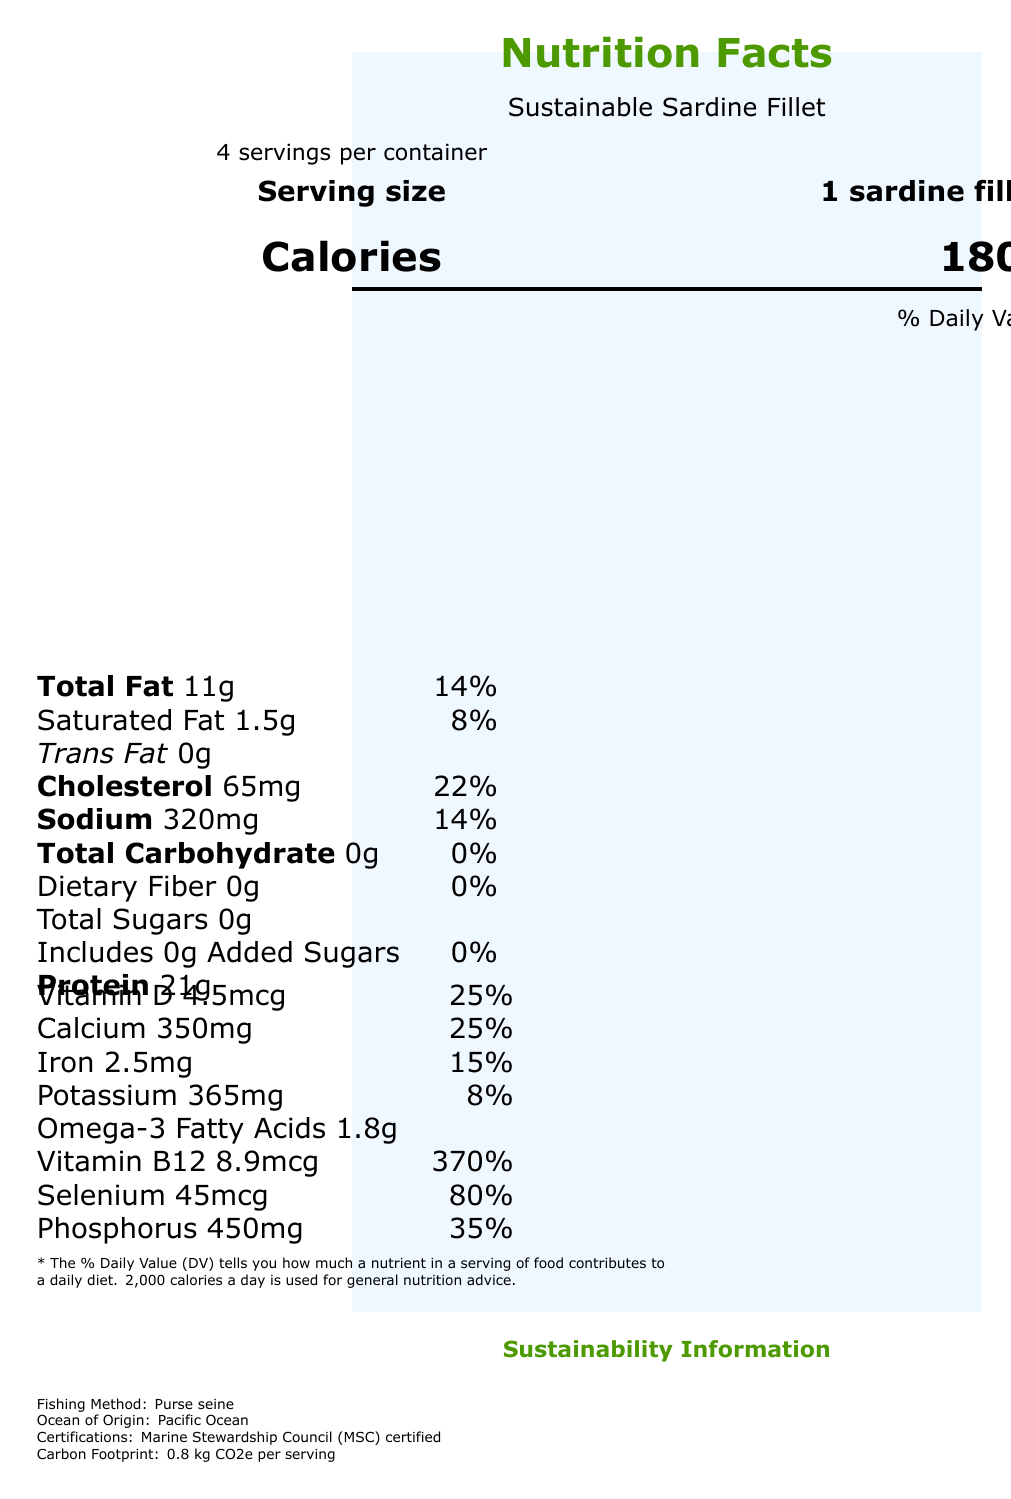what is the serving size? The serving size is mentioned as "1 sardine fillet (85g)" in the serving information section of the document.
Answer: 1 sardine fillet (85g) how many servings are there per container? The document states there are "4 servings per container" in the serving information section.
Answer: 4 how many calories are in one serving? The calorie information section indicates that there are 180 calories in one serving.
Answer: 180 what is the daily value percentage of saturated fat? The document lists the daily value percentage of saturated fat as 8%.
Answer: 8% how much protein does one serving contain? The nutrient table shows one serving contains 21 grams of protein.
Answer: 21g what type of fishing method is used for the sardines? The sustainability information section states that the fishing method used is "Purse seine".
Answer: Purse seine how much omega-3 fatty acids does one serving contain? The vitamin and mineral table lists 1.8 grams of omega-3 fatty acids per serving.
Answer: 1.8g which organization certified the sustainability of the sardines? The certifications are listed under sustainability information, where it mentions "Marine Stewardship Council (MSC) certified".
Answer: Marine Stewardship Council (MSC) what percentage of daily calcium value does one serving provide? The vitamin and mineral table shows that one serving provides 25% of the daily value for calcium.
Answer: 25% the document mentions three preparation tips for sardines. (Choose one not listed) A. Grill with lemon and herbs B. Bake with garlic and tomatoes C. Mash with avocado D. Add to pasta dishes The preparation tips listed are "Grill with lemon and herbs," "Mash with avocado," and "Add to pasta dishes." "Bake with garlic and tomatoes" is not listed.
Answer: B what is the carbon footprint per serving of this fish dish? A. 0.5 kg CO2e B. 0.8 kg CO2e C. 1.0 kg CO2e D. 1.2 kg CO2e The sustainability information section lists the carbon footprint per serving as "0.8 kg CO2e."
Answer: B is there any added sugar in the sardine fillet? The document shows the amount of added sugars as "0g" and a daily value of "0%," indicating no added sugars.
Answer: No summarize the main idea of the document. The document offers a comprehensive overview of the nutritional values, environmental benefits, and certification information for sardines, emphasizing their sustainability and health advantages.
Answer: The document provides detailed nutrition information for a sustainable sardine fillet, including serving size, calories, nutrient content, and daily value percentages. It highlights the sustainability aspects of the sardines, such as the fishing method, certifications, and carbon footprint, as well as preparation tips and health benefits. what is the daily value percentage of total carbohydrates? The nutrient table mentions the daily value percentage of total carbohydrates is 0%.
Answer: 0% how much cholesterol is in one serving? The nutrient table shows that there are 65 milligrams of cholesterol in one serving.
Answer: 65mg how much dietary fiber does one serving contain? The document states the amount of dietary fiber is "0g" and the daily value is also "0%," indicating there is no dietary fiber.
Answer: 0g what is the reproduction rate of the sardines? The document does not provide specific data on the reproduction rate of the sardines. This information is not available in the visual data.
Answer: Cannot be determined 